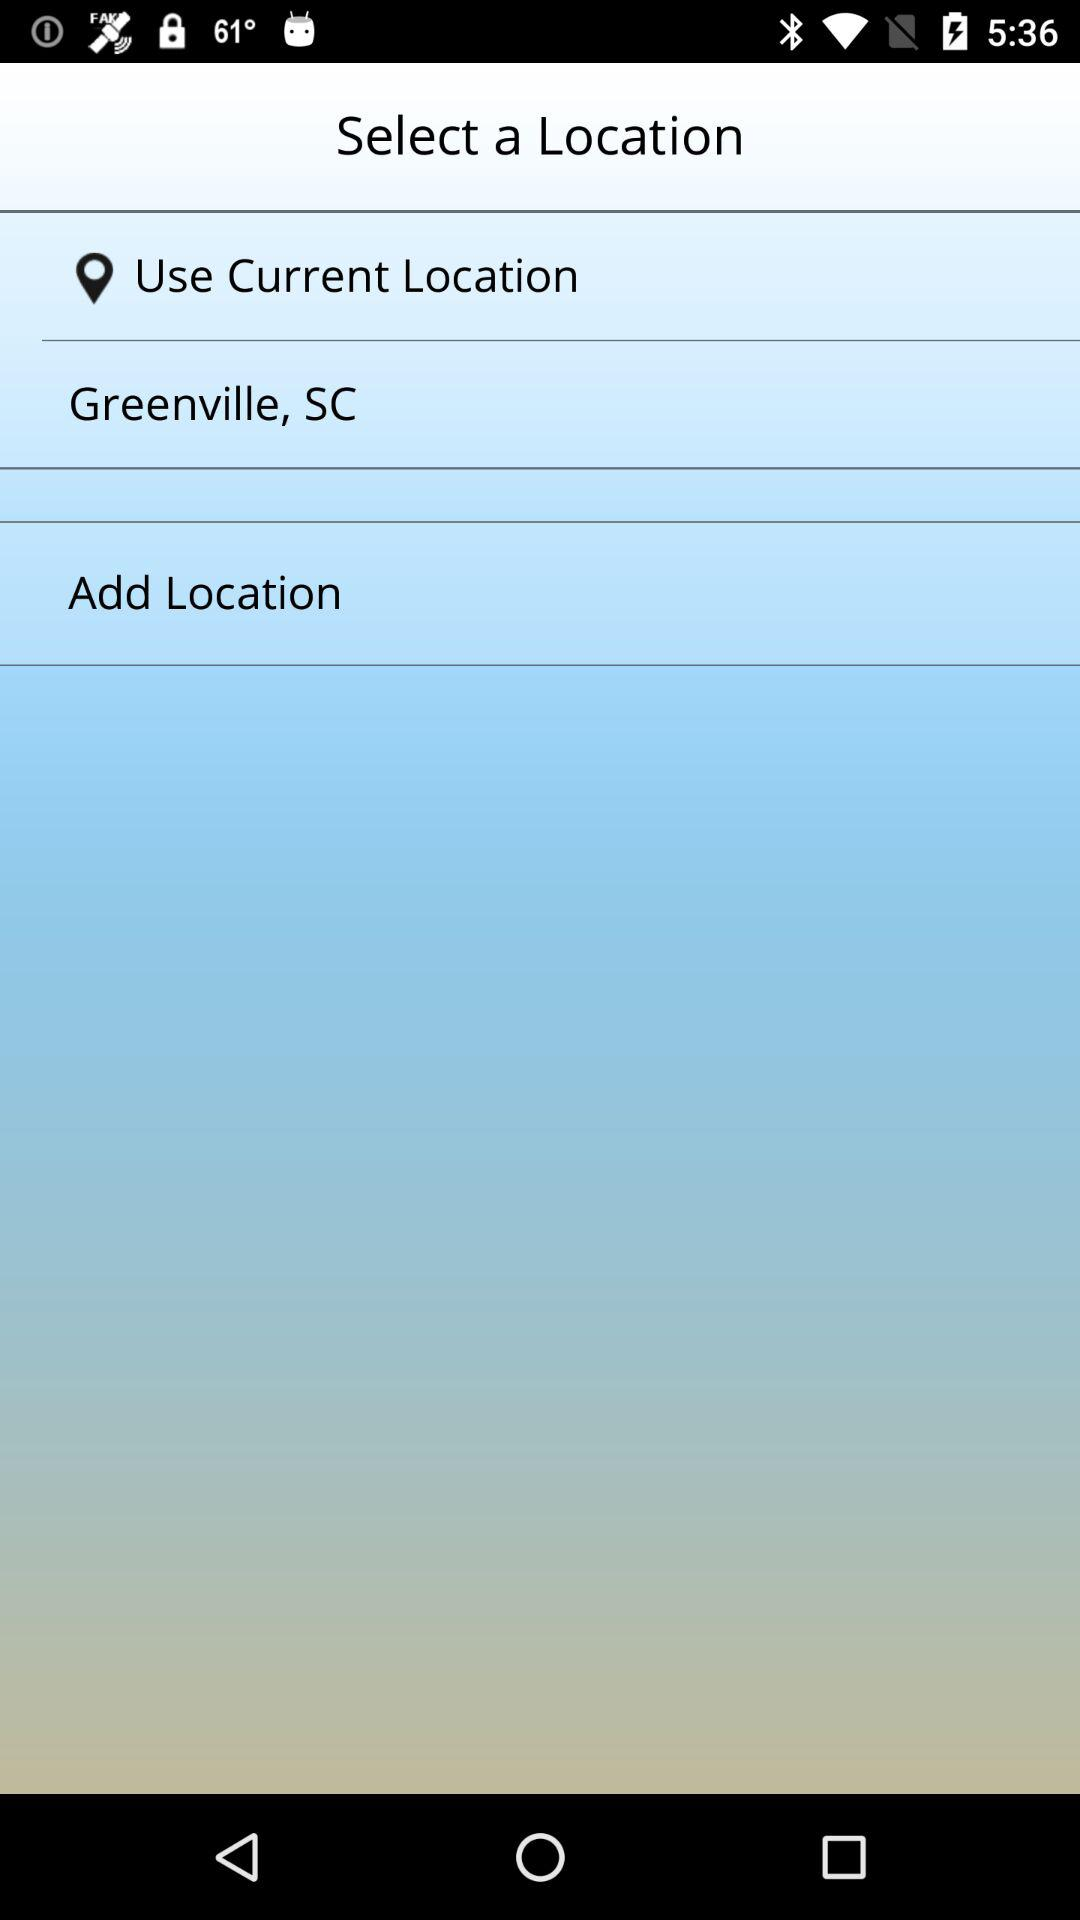What is the location? The location is Greenville, SC. 